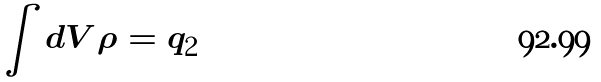Convert formula to latex. <formula><loc_0><loc_0><loc_500><loc_500>\int d V \rho = q _ { 2 }</formula> 